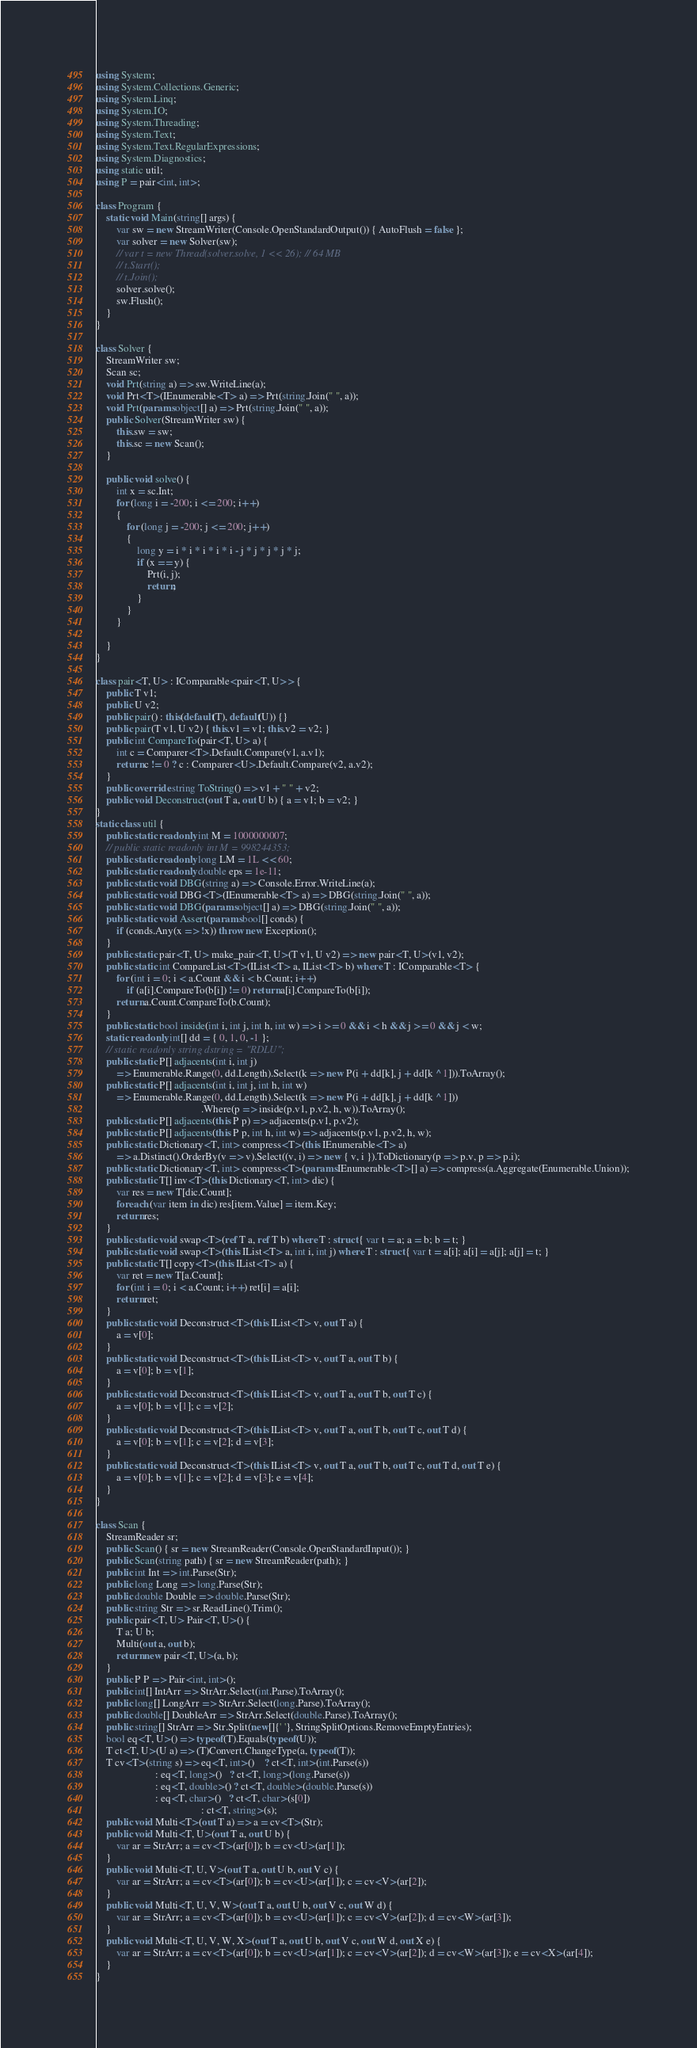<code> <loc_0><loc_0><loc_500><loc_500><_C#_>using System;
using System.Collections.Generic;
using System.Linq;
using System.IO;
using System.Threading;
using System.Text;
using System.Text.RegularExpressions;
using System.Diagnostics;
using static util;
using P = pair<int, int>;

class Program {
    static void Main(string[] args) {
        var sw = new StreamWriter(Console.OpenStandardOutput()) { AutoFlush = false };
        var solver = new Solver(sw);
        // var t = new Thread(solver.solve, 1 << 26); // 64 MB
        // t.Start();
        // t.Join();
        solver.solve();
        sw.Flush();
    }
}

class Solver {
    StreamWriter sw;
    Scan sc;
    void Prt(string a) => sw.WriteLine(a);
    void Prt<T>(IEnumerable<T> a) => Prt(string.Join(" ", a));
    void Prt(params object[] a) => Prt(string.Join(" ", a));
    public Solver(StreamWriter sw) {
        this.sw = sw;
        this.sc = new Scan();
    }

    public void solve() {
        int x = sc.Int;
        for (long i = -200; i <= 200; i++)
        {
            for (long j = -200; j <= 200; j++)
            {
                long y = i * i * i * i * i - j * j * j * j * j;
                if (x == y) {
                    Prt(i, j);
                    return;
                }
            }
        }

    }
}

class pair<T, U> : IComparable<pair<T, U>> {
    public T v1;
    public U v2;
    public pair() : this(default(T), default(U)) {}
    public pair(T v1, U v2) { this.v1 = v1; this.v2 = v2; }
    public int CompareTo(pair<T, U> a) {
        int c = Comparer<T>.Default.Compare(v1, a.v1);
        return c != 0 ? c : Comparer<U>.Default.Compare(v2, a.v2);
    }
    public override string ToString() => v1 + " " + v2;
    public void Deconstruct(out T a, out U b) { a = v1; b = v2; }
}
static class util {
    public static readonly int M = 1000000007;
    // public static readonly int M = 998244353;
    public static readonly long LM = 1L << 60;
    public static readonly double eps = 1e-11;
    public static void DBG(string a) => Console.Error.WriteLine(a);
    public static void DBG<T>(IEnumerable<T> a) => DBG(string.Join(" ", a));
    public static void DBG(params object[] a) => DBG(string.Join(" ", a));
    public static void Assert(params bool[] conds) {
        if (conds.Any(x => !x)) throw new Exception();
    }
    public static pair<T, U> make_pair<T, U>(T v1, U v2) => new pair<T, U>(v1, v2);
    public static int CompareList<T>(IList<T> a, IList<T> b) where T : IComparable<T> {
        for (int i = 0; i < a.Count && i < b.Count; i++)
            if (a[i].CompareTo(b[i]) != 0) return a[i].CompareTo(b[i]);
        return a.Count.CompareTo(b.Count);
    }
    public static bool inside(int i, int j, int h, int w) => i >= 0 && i < h && j >= 0 && j < w;
    static readonly int[] dd = { 0, 1, 0, -1 };
    // static readonly string dstring = "RDLU";
    public static P[] adjacents(int i, int j)
        => Enumerable.Range(0, dd.Length).Select(k => new P(i + dd[k], j + dd[k ^ 1])).ToArray();
    public static P[] adjacents(int i, int j, int h, int w)
        => Enumerable.Range(0, dd.Length).Select(k => new P(i + dd[k], j + dd[k ^ 1]))
                                         .Where(p => inside(p.v1, p.v2, h, w)).ToArray();
    public static P[] adjacents(this P p) => adjacents(p.v1, p.v2);
    public static P[] adjacents(this P p, int h, int w) => adjacents(p.v1, p.v2, h, w);
    public static Dictionary<T, int> compress<T>(this IEnumerable<T> a)
        => a.Distinct().OrderBy(v => v).Select((v, i) => new { v, i }).ToDictionary(p => p.v, p => p.i);
    public static Dictionary<T, int> compress<T>(params IEnumerable<T>[] a) => compress(a.Aggregate(Enumerable.Union));
    public static T[] inv<T>(this Dictionary<T, int> dic) {
        var res = new T[dic.Count];
        foreach (var item in dic) res[item.Value] = item.Key;
        return res;
    }
    public static void swap<T>(ref T a, ref T b) where T : struct { var t = a; a = b; b = t; }
    public static void swap<T>(this IList<T> a, int i, int j) where T : struct { var t = a[i]; a[i] = a[j]; a[j] = t; }
    public static T[] copy<T>(this IList<T> a) {
        var ret = new T[a.Count];
        for (int i = 0; i < a.Count; i++) ret[i] = a[i];
        return ret;
    }
    public static void Deconstruct<T>(this IList<T> v, out T a) {
        a = v[0];
    }
    public static void Deconstruct<T>(this IList<T> v, out T a, out T b) {
        a = v[0]; b = v[1];
    }
    public static void Deconstruct<T>(this IList<T> v, out T a, out T b, out T c) {
        a = v[0]; b = v[1]; c = v[2];
    }
    public static void Deconstruct<T>(this IList<T> v, out T a, out T b, out T c, out T d) {
        a = v[0]; b = v[1]; c = v[2]; d = v[3];
    }
    public static void Deconstruct<T>(this IList<T> v, out T a, out T b, out T c, out T d, out T e) {
        a = v[0]; b = v[1]; c = v[2]; d = v[3]; e = v[4];
    }
}

class Scan {
    StreamReader sr;
    public Scan() { sr = new StreamReader(Console.OpenStandardInput()); }
    public Scan(string path) { sr = new StreamReader(path); }
    public int Int => int.Parse(Str);
    public long Long => long.Parse(Str);
    public double Double => double.Parse(Str);
    public string Str => sr.ReadLine().Trim();
    public pair<T, U> Pair<T, U>() {
        T a; U b;
        Multi(out a, out b);
        return new pair<T, U>(a, b);
    }
    public P P => Pair<int, int>();
    public int[] IntArr => StrArr.Select(int.Parse).ToArray();
    public long[] LongArr => StrArr.Select(long.Parse).ToArray();
    public double[] DoubleArr => StrArr.Select(double.Parse).ToArray();
    public string[] StrArr => Str.Split(new[]{' '}, StringSplitOptions.RemoveEmptyEntries);
    bool eq<T, U>() => typeof(T).Equals(typeof(U));
    T ct<T, U>(U a) => (T)Convert.ChangeType(a, typeof(T));
    T cv<T>(string s) => eq<T, int>()    ? ct<T, int>(int.Parse(s))
                       : eq<T, long>()   ? ct<T, long>(long.Parse(s))
                       : eq<T, double>() ? ct<T, double>(double.Parse(s))
                       : eq<T, char>()   ? ct<T, char>(s[0])
                                         : ct<T, string>(s);
    public void Multi<T>(out T a) => a = cv<T>(Str);
    public void Multi<T, U>(out T a, out U b) {
        var ar = StrArr; a = cv<T>(ar[0]); b = cv<U>(ar[1]);
    }
    public void Multi<T, U, V>(out T a, out U b, out V c) {
        var ar = StrArr; a = cv<T>(ar[0]); b = cv<U>(ar[1]); c = cv<V>(ar[2]);
    }
    public void Multi<T, U, V, W>(out T a, out U b, out V c, out W d) {
        var ar = StrArr; a = cv<T>(ar[0]); b = cv<U>(ar[1]); c = cv<V>(ar[2]); d = cv<W>(ar[3]);
    }
    public void Multi<T, U, V, W, X>(out T a, out U b, out V c, out W d, out X e) {
        var ar = StrArr; a = cv<T>(ar[0]); b = cv<U>(ar[1]); c = cv<V>(ar[2]); d = cv<W>(ar[3]); e = cv<X>(ar[4]);
    }
}
</code> 